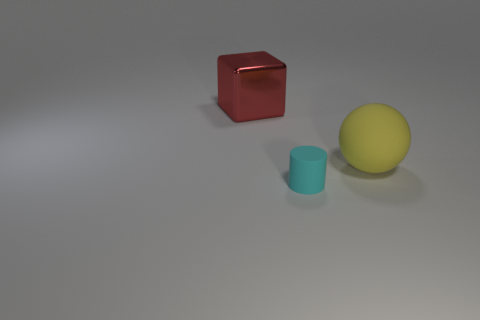How many small cyan matte things are there?
Your answer should be very brief. 1. There is a thing that is to the right of the cyan object; what size is it?
Ensure brevity in your answer.  Large. What number of red metallic things are the same size as the red cube?
Provide a succinct answer. 0. The thing that is both to the right of the big red metallic thing and behind the small cylinder is made of what material?
Provide a short and direct response. Rubber. There is another thing that is the same size as the red metallic thing; what material is it?
Make the answer very short. Rubber. There is a thing that is right of the tiny cylinder left of the big object on the right side of the red metal cube; how big is it?
Ensure brevity in your answer.  Large. What is the size of the cyan object that is made of the same material as the big yellow thing?
Provide a succinct answer. Small. Is the size of the metal thing the same as the rubber object that is in front of the sphere?
Keep it short and to the point. No. The large object that is behind the large yellow object has what shape?
Offer a terse response. Cube. Is there a shiny block that is behind the big thing that is behind the big thing right of the large red cube?
Offer a terse response. No. 